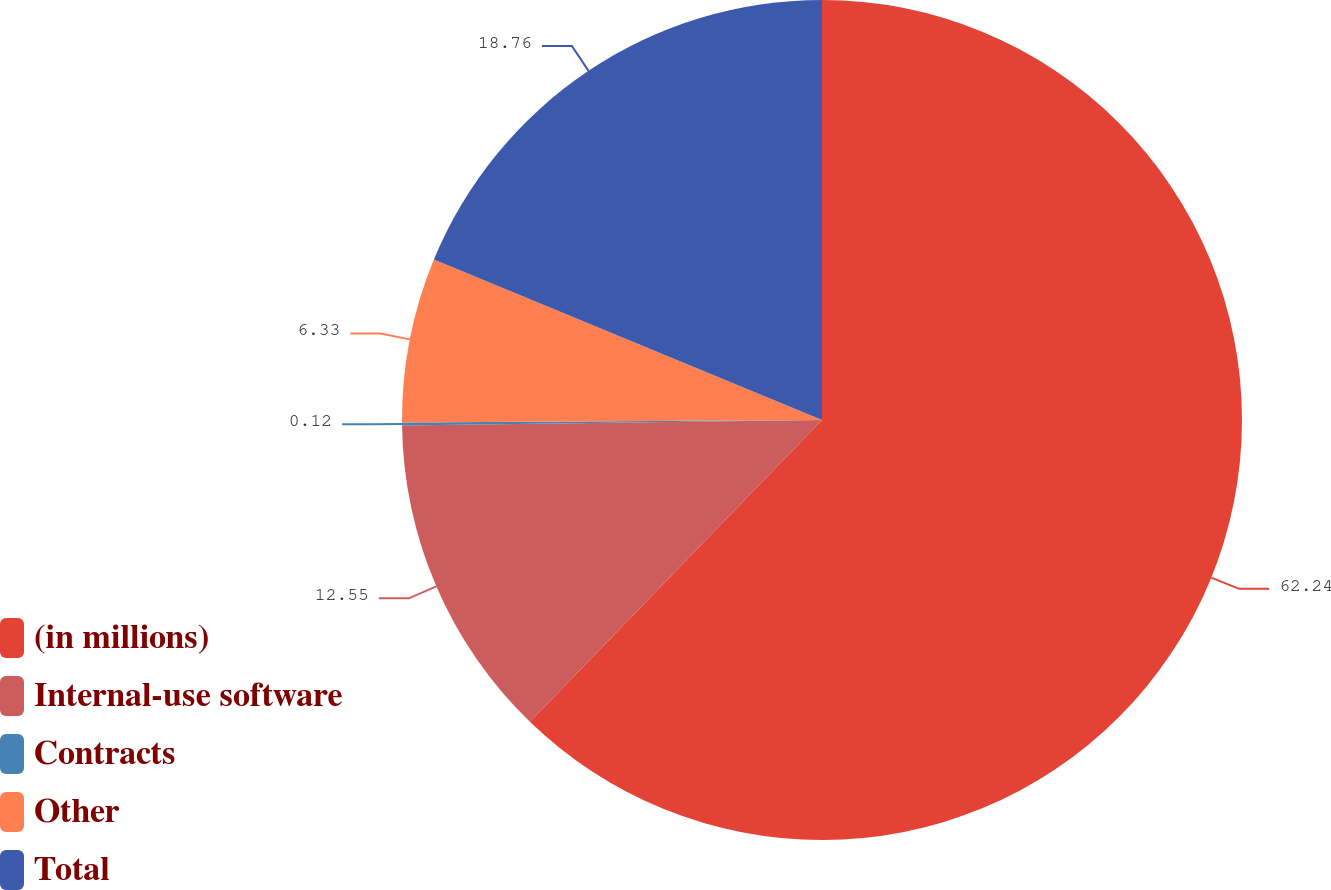Convert chart to OTSL. <chart><loc_0><loc_0><loc_500><loc_500><pie_chart><fcel>(in millions)<fcel>Internal-use software<fcel>Contracts<fcel>Other<fcel>Total<nl><fcel>62.24%<fcel>12.55%<fcel>0.12%<fcel>6.33%<fcel>18.76%<nl></chart> 